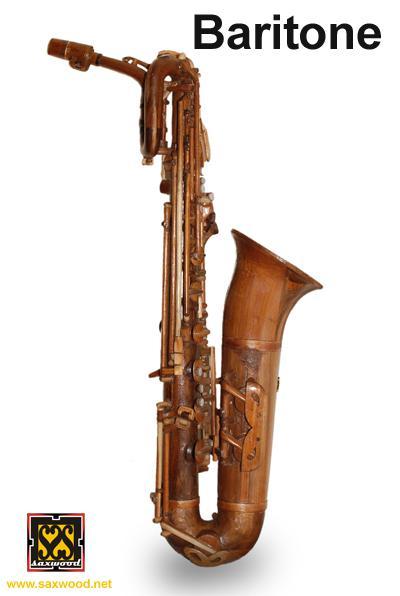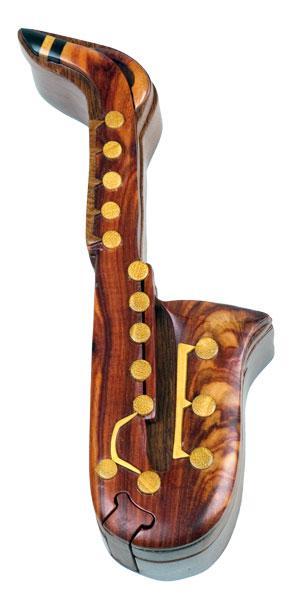The first image is the image on the left, the second image is the image on the right. Assess this claim about the two images: "An image shows a wooden bamboo on a stand with light behind it creating deep shadow.". Correct or not? Answer yes or no. No. The first image is the image on the left, the second image is the image on the right. Given the left and right images, does the statement "The saxophone in one of the images is on a stand." hold true? Answer yes or no. No. 